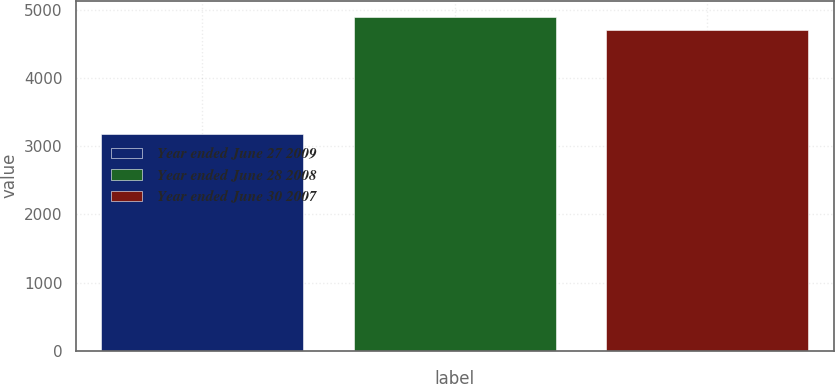Convert chart. <chart><loc_0><loc_0><loc_500><loc_500><bar_chart><fcel>Year ended June 27 2009<fcel>Year ended June 28 2008<fcel>Year ended June 30 2007<nl><fcel>3174<fcel>4889<fcel>4712<nl></chart> 